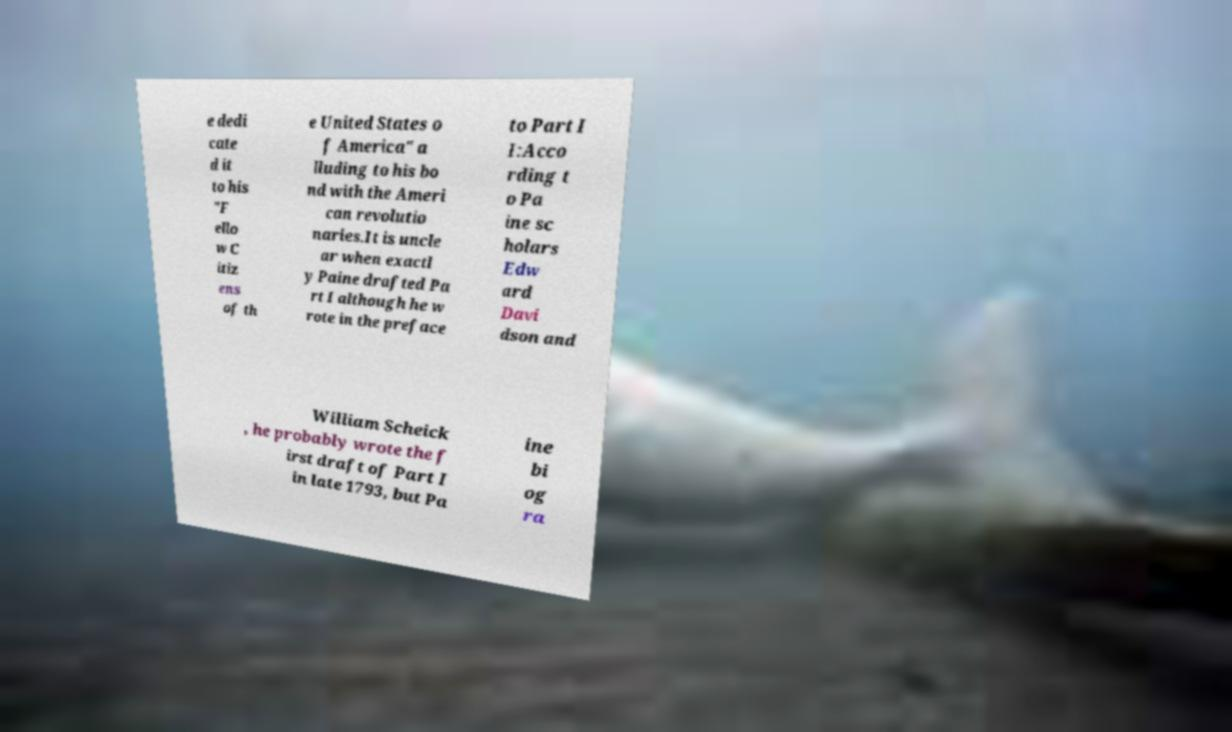For documentation purposes, I need the text within this image transcribed. Could you provide that? e dedi cate d it to his "F ello w C itiz ens of th e United States o f America" a lluding to his bo nd with the Ameri can revolutio naries.It is uncle ar when exactl y Paine drafted Pa rt I although he w rote in the preface to Part I I:Acco rding t o Pa ine sc holars Edw ard Davi dson and William Scheick , he probably wrote the f irst draft of Part I in late 1793, but Pa ine bi og ra 